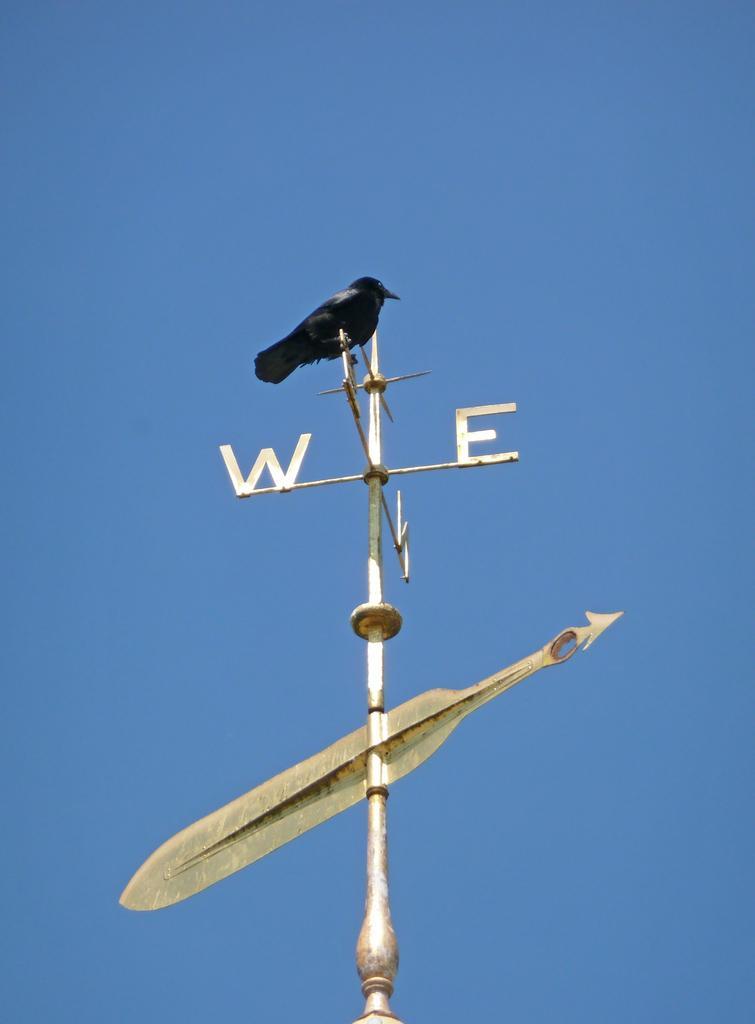Please provide a concise description of this image. In this image, we can see a bird on the direction pole. We can see the sky. 